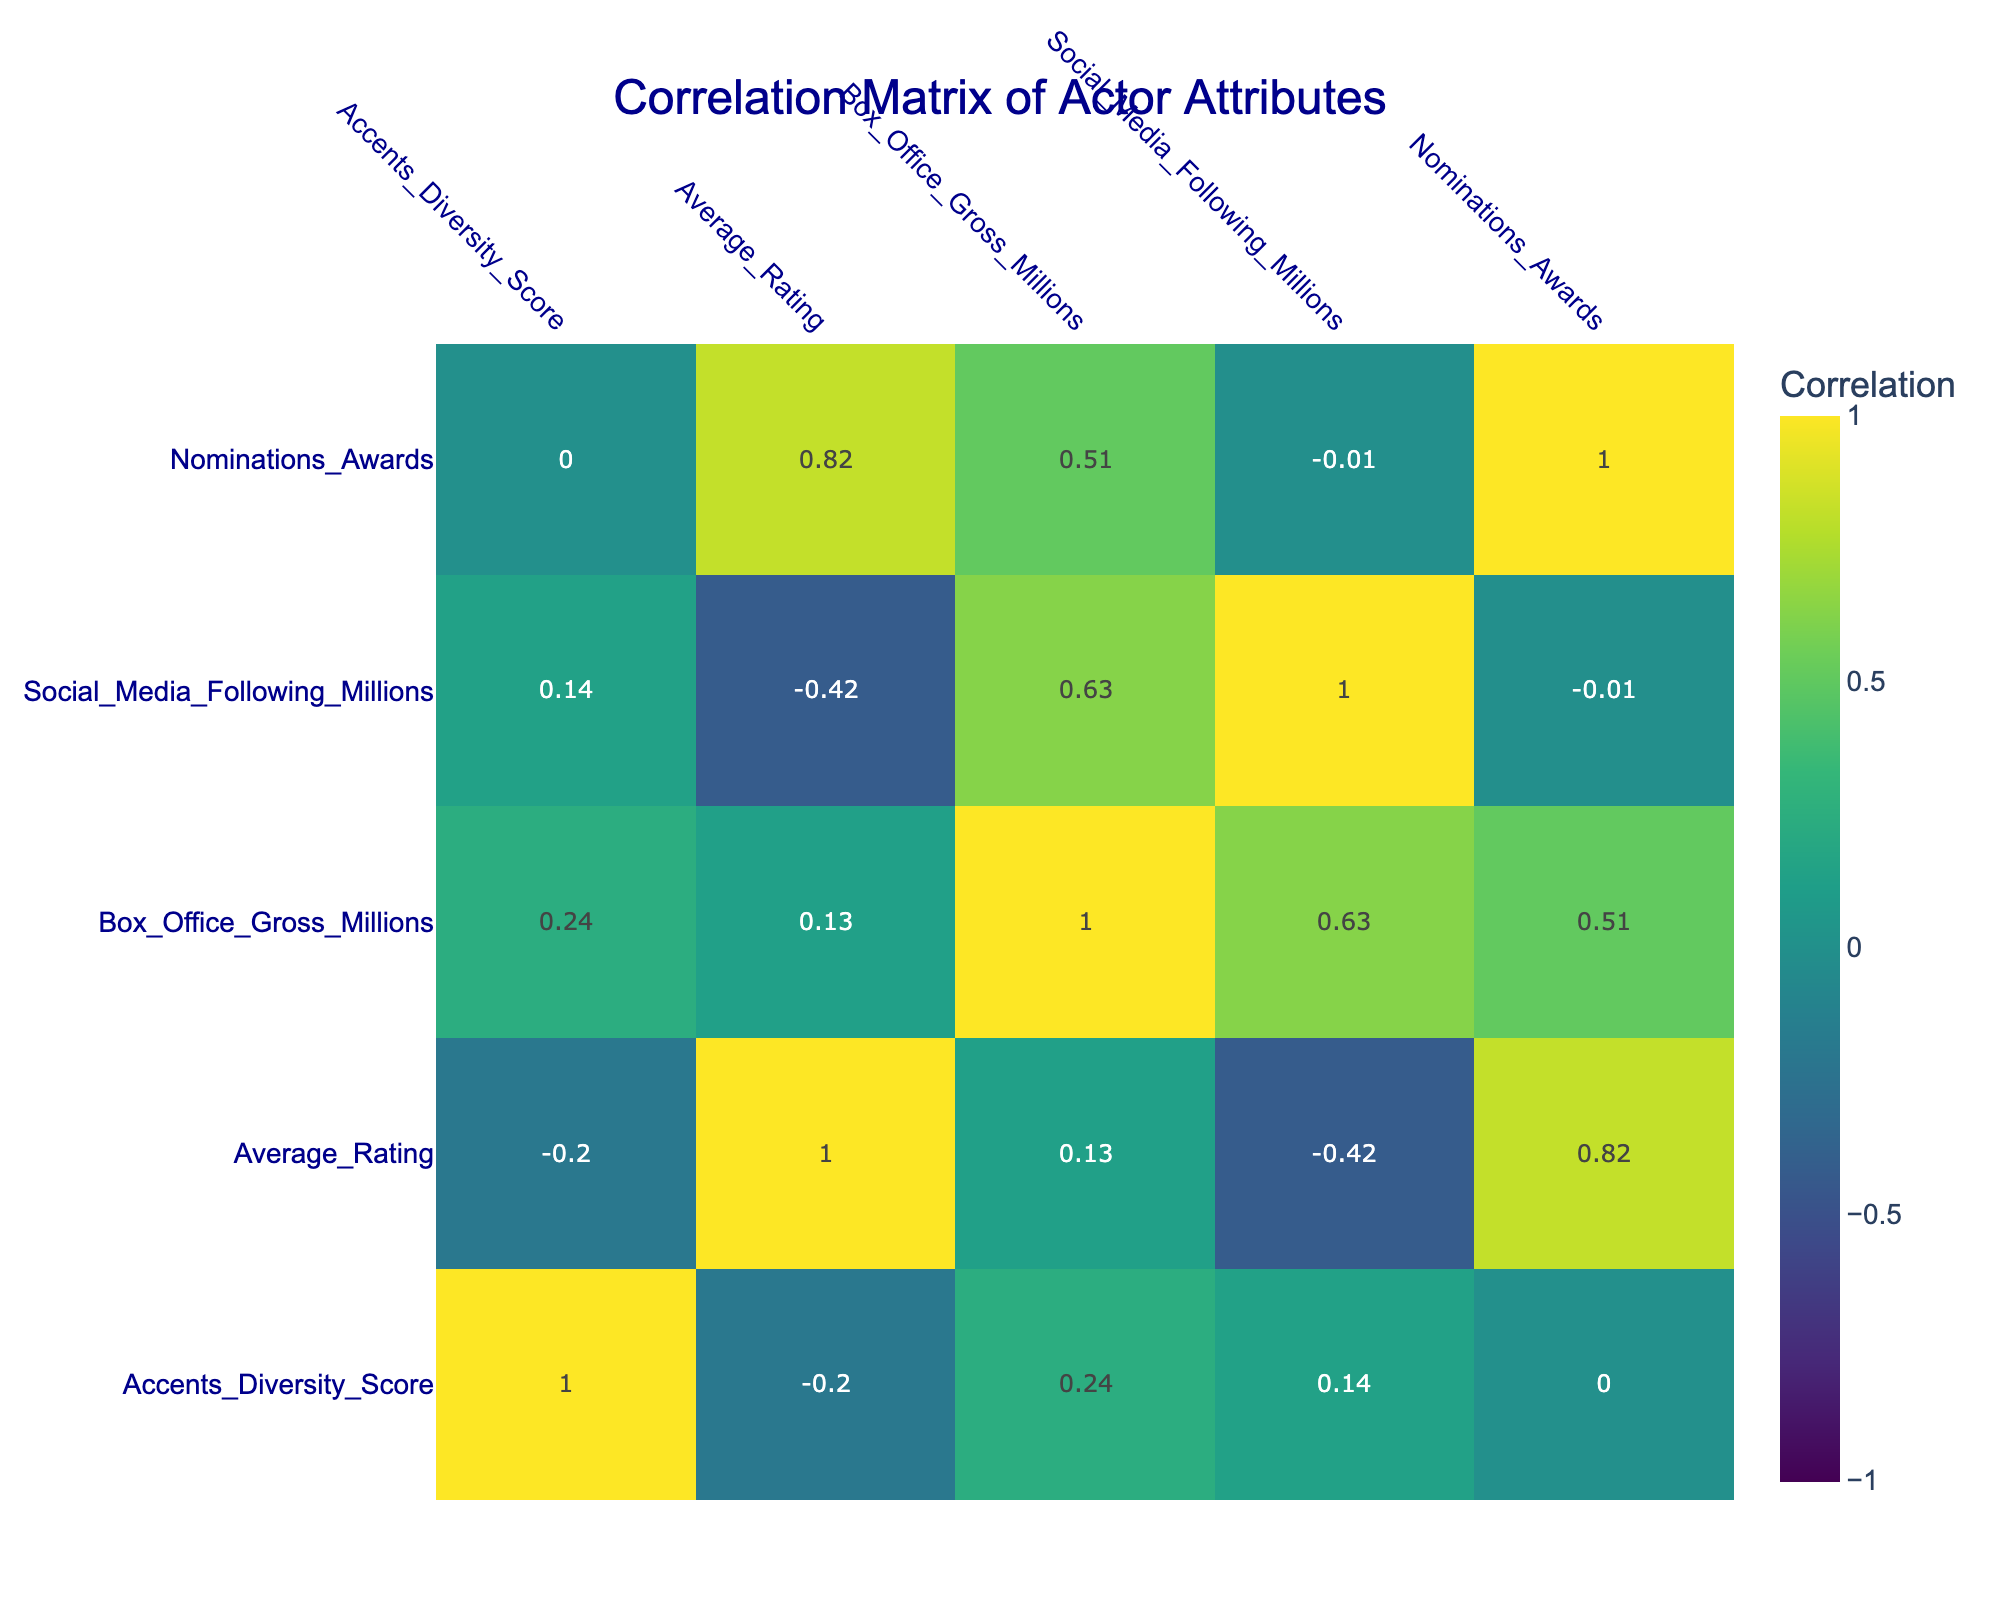What is the Accents Diversity Score of Meryl Streep? The table clearly lists Meryl Streep's Accents Diversity Score, which can be found in the corresponding row under that column. The score is 9.
Answer: 9 Which actor has the highest Box Office Gross? By reviewing the Box Office Gross values in the table, we can see that Leonardo DiCaprio has the highest value at 1500 million.
Answer: 1500 What is the average Accents Diversity Score of actors with more than 20 million social media following? First, we identify the actors with more than 20 million social media following: Meryl Streep (9), Sofia Vergara (8), and Leonardo DiCaprio (4). Next, we calculate their average: (9 + 8 + 4)/3 = 21/3 = 7.
Answer: 7 Is having a high Accents Diversity Score always associated with a high Average Rating? To answer this, we compare the Accents Diversity Scores and Average Ratings across the actors. For example, Meryl Streep has a high score (9) and a high rating (8.9), but Sofia Vergara has a high score (8) and a low rating (7.9). This indicates that a high score does not guarantee a high rating.
Answer: No Which actor with an Accents Diversity Score of 7 has the highest Average Rating? From the table, we see that there are two actors with a score of 7: Daniel Day-Lewis (average rating 9.1) and Tom Hardy (average rating 8.4). Thus, Daniel Day-Lewis has the highest rating among them.
Answer: Daniel Day-Lewis What is the relationship between Average Rating and Nominations Awards for actors? By examining the correlation values in the table, we can assess the relationship between these two columns. A positive correlation value would suggest that as the Average Rating increases, so do the Nominations Awards, while a negative value would indicate the opposite.
Answer: Positive correlation Which two attributes have the strongest positive correlation? By reviewing the correlation matrix, we identify the pairs with the highest positive correlation value. In this case, Accents Diversity Score and Nominations Awards reflect a strong positive correlation.
Answer: Accents Diversity Score and Nominations Awards Are there any actors with a social media following greater than 30 million who have received more than 15 nominations? Looking at the data, Leonardo DiCaprio has a following of 30 million and received 20 nominations. Therefore, yes, there is at least one actor meeting these criteria.
Answer: Yes What is the difference in Box Office Gross between the actor with the highest and lowest scores? The actor with the highest Box Office Gross is Meryl Streep with 1500 million, and the lowest Box Office Gross in the table is Daniel Day-Lewis with 280 million. Calculating the difference yields 1500 - 280 = 1220 million.
Answer: 1220 million 